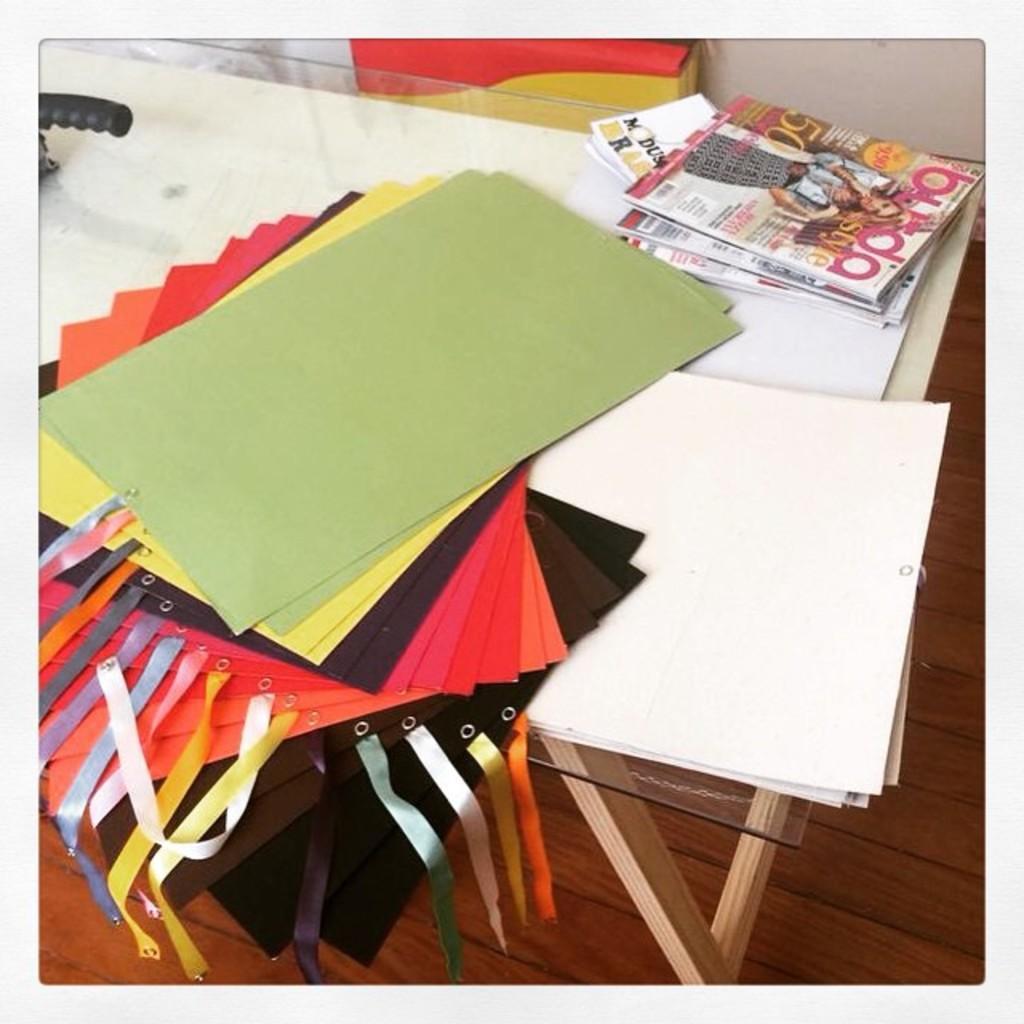Describe this image in one or two sentences. We can see papers,books and objects on the glass table. Background we can see wall and box. 